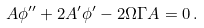<formula> <loc_0><loc_0><loc_500><loc_500>A \phi ^ { \prime \prime } + 2 A ^ { \prime } \phi ^ { \prime } - 2 \Omega \Gamma A = 0 \, .</formula> 